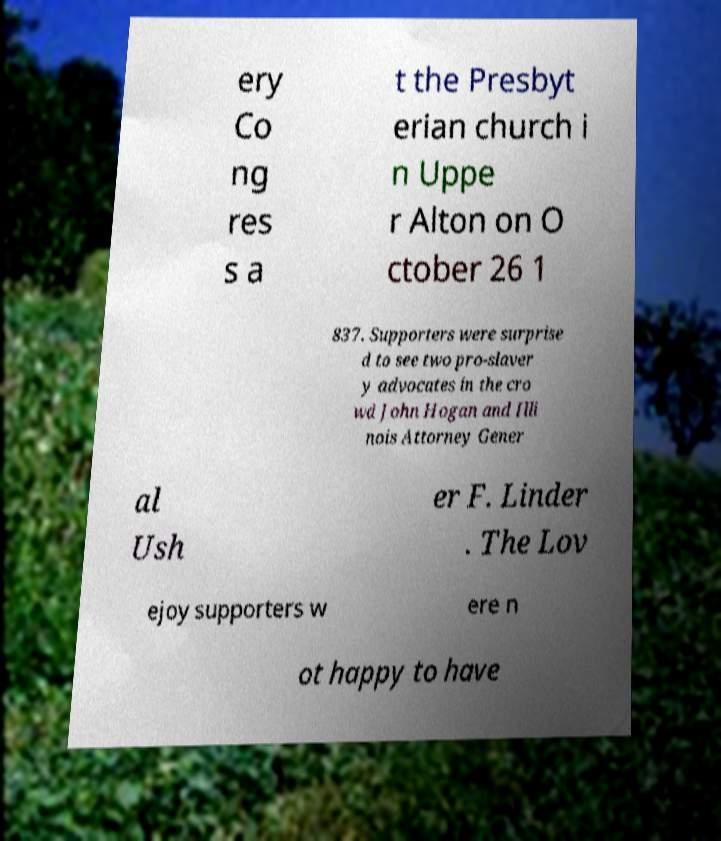There's text embedded in this image that I need extracted. Can you transcribe it verbatim? ery Co ng res s a t the Presbyt erian church i n Uppe r Alton on O ctober 26 1 837. Supporters were surprise d to see two pro-slaver y advocates in the cro wd John Hogan and Illi nois Attorney Gener al Ush er F. Linder . The Lov ejoy supporters w ere n ot happy to have 